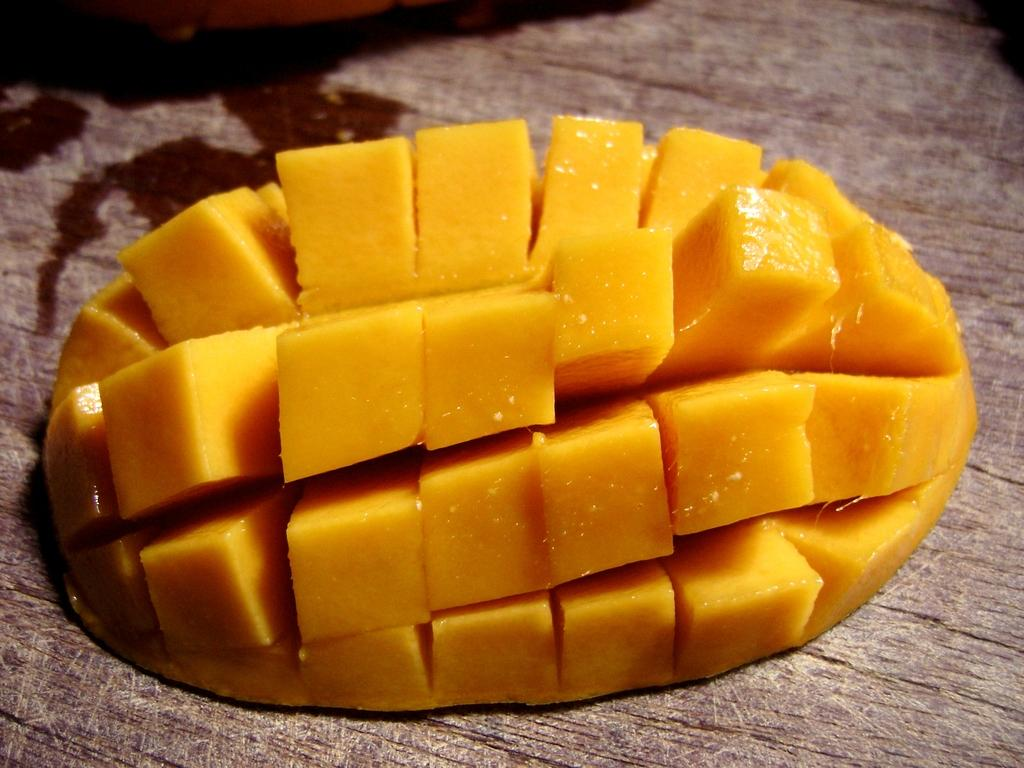What type of fruit is visible in the image? There are mango slices in the image. What is the mango slices placed on? The mango slices are on a wooden surface. What type of beef is being cooked on the wooden surface in the image? There is no beef or cooking activity present in the image; it only features mango slices on a wooden surface. 